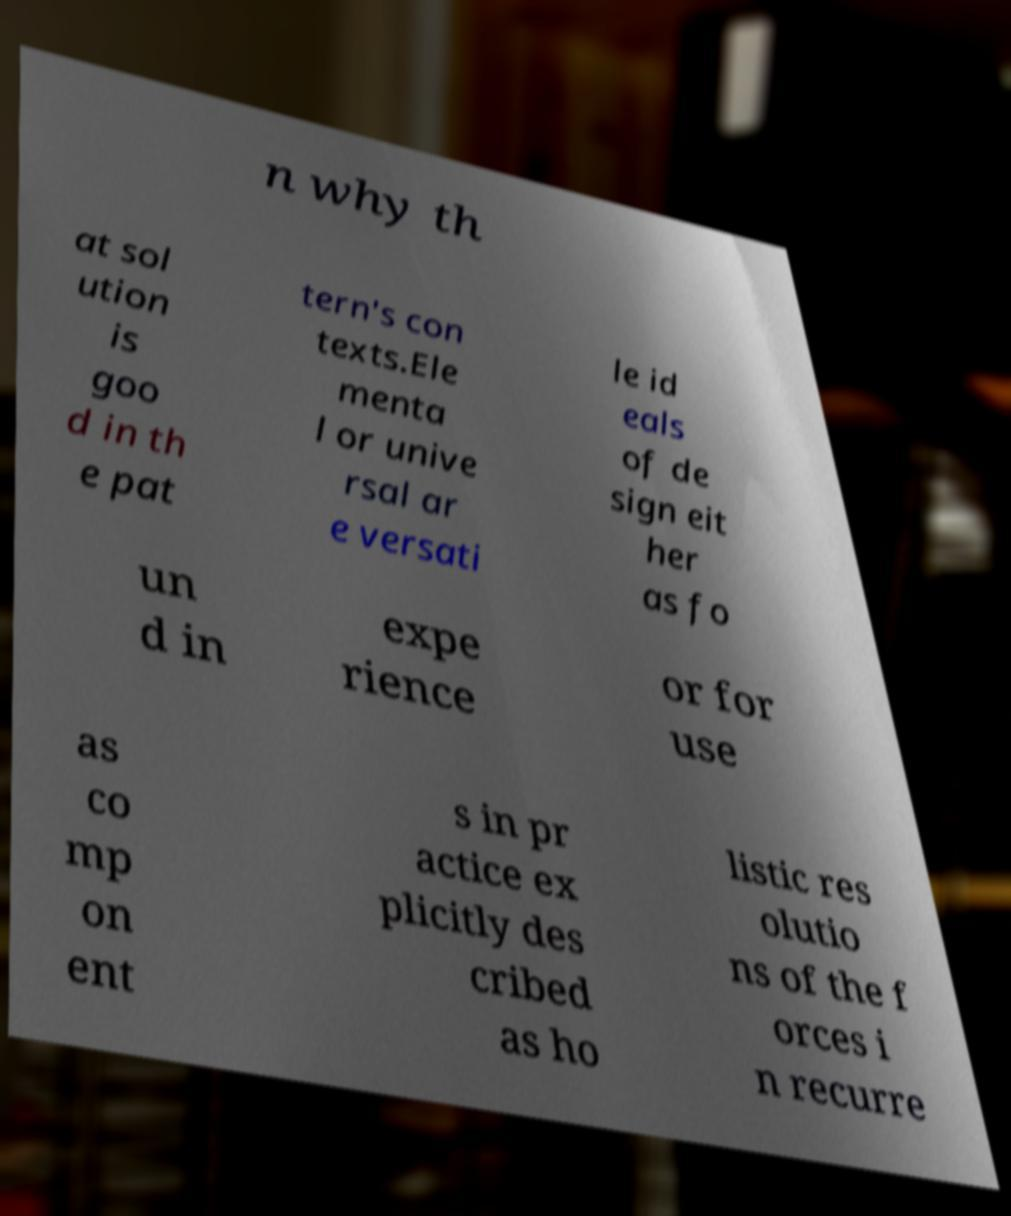Can you read and provide the text displayed in the image?This photo seems to have some interesting text. Can you extract and type it out for me? n why th at sol ution is goo d in th e pat tern's con texts.Ele menta l or unive rsal ar e versati le id eals of de sign eit her as fo un d in expe rience or for use as co mp on ent s in pr actice ex plicitly des cribed as ho listic res olutio ns of the f orces i n recurre 